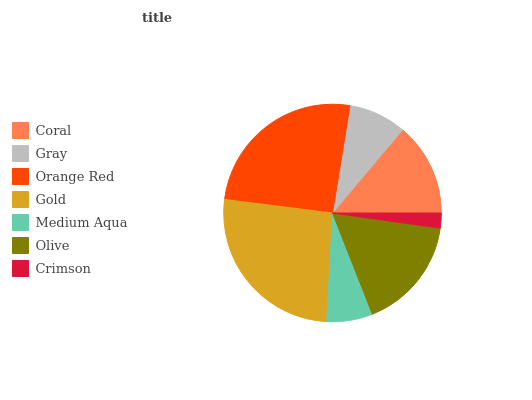Is Crimson the minimum?
Answer yes or no. Yes. Is Gold the maximum?
Answer yes or no. Yes. Is Gray the minimum?
Answer yes or no. No. Is Gray the maximum?
Answer yes or no. No. Is Coral greater than Gray?
Answer yes or no. Yes. Is Gray less than Coral?
Answer yes or no. Yes. Is Gray greater than Coral?
Answer yes or no. No. Is Coral less than Gray?
Answer yes or no. No. Is Coral the high median?
Answer yes or no. Yes. Is Coral the low median?
Answer yes or no. Yes. Is Medium Aqua the high median?
Answer yes or no. No. Is Medium Aqua the low median?
Answer yes or no. No. 